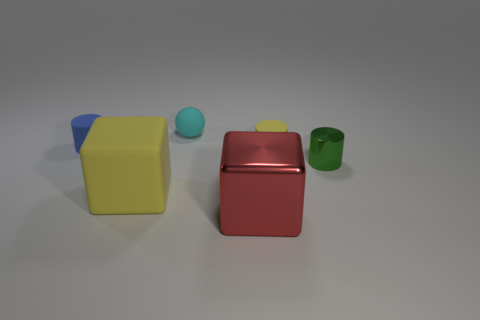There is a object that is in front of the small green metallic cylinder and behind the red shiny thing; what is its material?
Your response must be concise. Rubber. Is the size of the cylinder that is on the right side of the yellow rubber cylinder the same as the sphere?
Offer a terse response. Yes. What is the shape of the large red shiny object?
Offer a terse response. Cube. How many tiny yellow things have the same shape as the green metal object?
Your answer should be very brief. 1. How many matte objects are both behind the yellow cube and on the right side of the blue object?
Your response must be concise. 2. The big shiny object has what color?
Provide a succinct answer. Red. Is there a big block made of the same material as the yellow cylinder?
Make the answer very short. Yes. Is there a shiny object left of the matte cylinder right of the rubber cylinder to the left of the red metal cube?
Provide a succinct answer. Yes. Are there any tiny matte objects in front of the cyan thing?
Provide a succinct answer. Yes. Are there any small things that have the same color as the large rubber cube?
Offer a very short reply. Yes. 